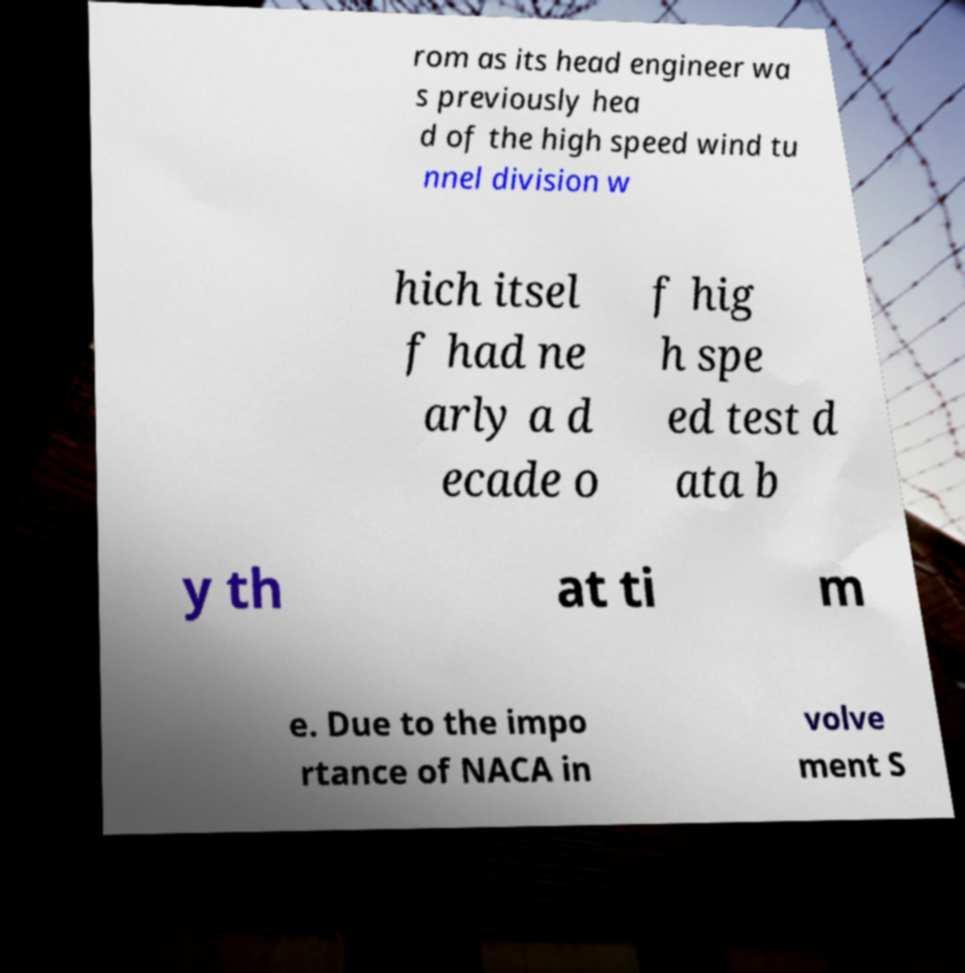Could you extract and type out the text from this image? rom as its head engineer wa s previously hea d of the high speed wind tu nnel division w hich itsel f had ne arly a d ecade o f hig h spe ed test d ata b y th at ti m e. Due to the impo rtance of NACA in volve ment S 